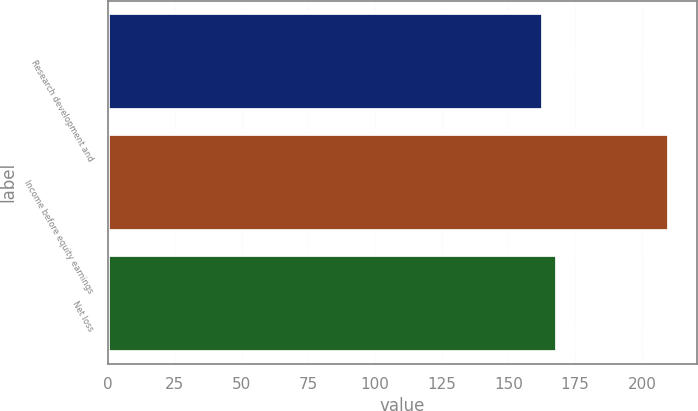Convert chart. <chart><loc_0><loc_0><loc_500><loc_500><bar_chart><fcel>Research development and<fcel>Income before equity earnings<fcel>Net loss<nl><fcel>163<fcel>210<fcel>168<nl></chart> 